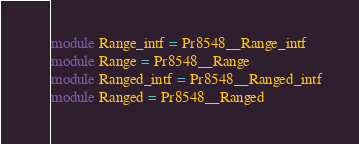<code> <loc_0><loc_0><loc_500><loc_500><_OCaml_>module Range_intf = Pr8548__Range_intf
module Range = Pr8548__Range
module Ranged_intf = Pr8548__Ranged_intf
module Ranged = Pr8548__Ranged
</code> 